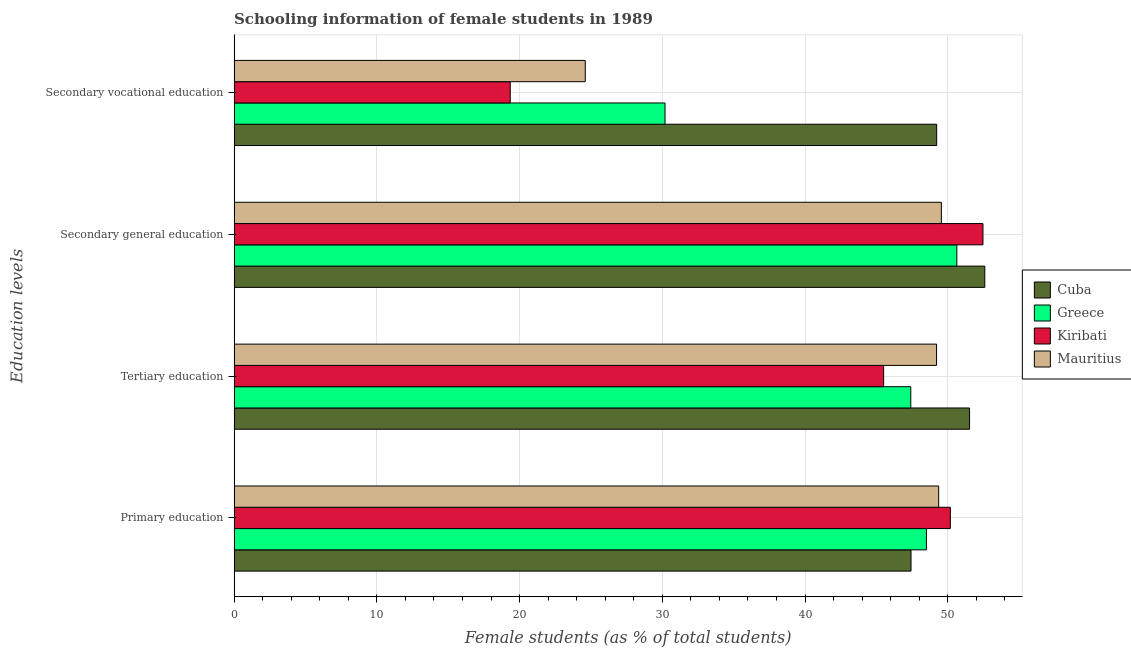How many different coloured bars are there?
Ensure brevity in your answer.  4. Are the number of bars on each tick of the Y-axis equal?
Ensure brevity in your answer.  Yes. How many bars are there on the 1st tick from the top?
Your answer should be compact. 4. How many bars are there on the 1st tick from the bottom?
Provide a succinct answer. 4. What is the label of the 2nd group of bars from the top?
Give a very brief answer. Secondary general education. What is the percentage of female students in tertiary education in Kiribati?
Ensure brevity in your answer.  45.5. Across all countries, what is the maximum percentage of female students in secondary education?
Offer a very short reply. 52.59. Across all countries, what is the minimum percentage of female students in secondary education?
Offer a very short reply. 49.55. In which country was the percentage of female students in tertiary education maximum?
Give a very brief answer. Cuba. In which country was the percentage of female students in primary education minimum?
Keep it short and to the point. Cuba. What is the total percentage of female students in secondary vocational education in the graph?
Provide a succinct answer. 123.35. What is the difference between the percentage of female students in tertiary education in Cuba and that in Mauritius?
Your response must be concise. 2.31. What is the difference between the percentage of female students in secondary vocational education in Cuba and the percentage of female students in tertiary education in Mauritius?
Your answer should be very brief. 0.01. What is the average percentage of female students in tertiary education per country?
Offer a very short reply. 48.41. What is the difference between the percentage of female students in primary education and percentage of female students in secondary education in Mauritius?
Provide a short and direct response. -0.19. What is the ratio of the percentage of female students in tertiary education in Cuba to that in Kiribati?
Provide a succinct answer. 1.13. Is the percentage of female students in secondary vocational education in Cuba less than that in Greece?
Offer a terse response. No. Is the difference between the percentage of female students in tertiary education in Greece and Kiribati greater than the difference between the percentage of female students in secondary vocational education in Greece and Kiribati?
Provide a short and direct response. No. What is the difference between the highest and the second highest percentage of female students in primary education?
Give a very brief answer. 0.82. What is the difference between the highest and the lowest percentage of female students in primary education?
Ensure brevity in your answer.  2.76. In how many countries, is the percentage of female students in secondary education greater than the average percentage of female students in secondary education taken over all countries?
Provide a succinct answer. 2. Is the sum of the percentage of female students in secondary vocational education in Mauritius and Greece greater than the maximum percentage of female students in primary education across all countries?
Give a very brief answer. Yes. What does the 3rd bar from the bottom in Tertiary education represents?
Keep it short and to the point. Kiribati. Is it the case that in every country, the sum of the percentage of female students in primary education and percentage of female students in tertiary education is greater than the percentage of female students in secondary education?
Your answer should be compact. Yes. How many countries are there in the graph?
Keep it short and to the point. 4. Where does the legend appear in the graph?
Offer a very short reply. Center right. How are the legend labels stacked?
Your answer should be compact. Vertical. What is the title of the graph?
Provide a succinct answer. Schooling information of female students in 1989. Does "Greenland" appear as one of the legend labels in the graph?
Offer a terse response. No. What is the label or title of the X-axis?
Your answer should be compact. Female students (as % of total students). What is the label or title of the Y-axis?
Offer a terse response. Education levels. What is the Female students (as % of total students) in Cuba in Primary education?
Provide a short and direct response. 47.42. What is the Female students (as % of total students) in Greece in Primary education?
Make the answer very short. 48.5. What is the Female students (as % of total students) of Kiribati in Primary education?
Make the answer very short. 50.18. What is the Female students (as % of total students) of Mauritius in Primary education?
Your response must be concise. 49.36. What is the Female students (as % of total students) of Cuba in Tertiary education?
Your answer should be compact. 51.52. What is the Female students (as % of total students) in Greece in Tertiary education?
Ensure brevity in your answer.  47.41. What is the Female students (as % of total students) of Kiribati in Tertiary education?
Your response must be concise. 45.5. What is the Female students (as % of total students) of Mauritius in Tertiary education?
Provide a succinct answer. 49.21. What is the Female students (as % of total students) in Cuba in Secondary general education?
Make the answer very short. 52.59. What is the Female students (as % of total students) in Greece in Secondary general education?
Offer a very short reply. 50.63. What is the Female students (as % of total students) in Kiribati in Secondary general education?
Offer a very short reply. 52.46. What is the Female students (as % of total students) in Mauritius in Secondary general education?
Provide a short and direct response. 49.55. What is the Female students (as % of total students) of Cuba in Secondary vocational education?
Your answer should be very brief. 49.22. What is the Female students (as % of total students) in Greece in Secondary vocational education?
Make the answer very short. 30.19. What is the Female students (as % of total students) in Kiribati in Secondary vocational education?
Keep it short and to the point. 19.34. What is the Female students (as % of total students) of Mauritius in Secondary vocational education?
Provide a short and direct response. 24.6. Across all Education levels, what is the maximum Female students (as % of total students) in Cuba?
Make the answer very short. 52.59. Across all Education levels, what is the maximum Female students (as % of total students) of Greece?
Offer a terse response. 50.63. Across all Education levels, what is the maximum Female students (as % of total students) of Kiribati?
Make the answer very short. 52.46. Across all Education levels, what is the maximum Female students (as % of total students) of Mauritius?
Your answer should be very brief. 49.55. Across all Education levels, what is the minimum Female students (as % of total students) of Cuba?
Your response must be concise. 47.42. Across all Education levels, what is the minimum Female students (as % of total students) of Greece?
Offer a terse response. 30.19. Across all Education levels, what is the minimum Female students (as % of total students) of Kiribati?
Provide a short and direct response. 19.34. Across all Education levels, what is the minimum Female students (as % of total students) of Mauritius?
Make the answer very short. 24.6. What is the total Female students (as % of total students) of Cuba in the graph?
Your response must be concise. 200.76. What is the total Female students (as % of total students) of Greece in the graph?
Provide a succinct answer. 176.73. What is the total Female students (as % of total students) of Kiribati in the graph?
Make the answer very short. 167.49. What is the total Female students (as % of total students) of Mauritius in the graph?
Your answer should be very brief. 172.73. What is the difference between the Female students (as % of total students) of Cuba in Primary education and that in Tertiary education?
Make the answer very short. -4.1. What is the difference between the Female students (as % of total students) of Greece in Primary education and that in Tertiary education?
Provide a succinct answer. 1.09. What is the difference between the Female students (as % of total students) in Kiribati in Primary education and that in Tertiary education?
Offer a terse response. 4.67. What is the difference between the Female students (as % of total students) of Mauritius in Primary education and that in Tertiary education?
Offer a terse response. 0.15. What is the difference between the Female students (as % of total students) in Cuba in Primary education and that in Secondary general education?
Keep it short and to the point. -5.17. What is the difference between the Female students (as % of total students) in Greece in Primary education and that in Secondary general education?
Your answer should be very brief. -2.13. What is the difference between the Female students (as % of total students) of Kiribati in Primary education and that in Secondary general education?
Give a very brief answer. -2.29. What is the difference between the Female students (as % of total students) of Mauritius in Primary education and that in Secondary general education?
Offer a very short reply. -0.19. What is the difference between the Female students (as % of total students) of Cuba in Primary education and that in Secondary vocational education?
Provide a succinct answer. -1.8. What is the difference between the Female students (as % of total students) in Greece in Primary education and that in Secondary vocational education?
Give a very brief answer. 18.31. What is the difference between the Female students (as % of total students) in Kiribati in Primary education and that in Secondary vocational education?
Your answer should be very brief. 30.83. What is the difference between the Female students (as % of total students) of Mauritius in Primary education and that in Secondary vocational education?
Your answer should be very brief. 24.76. What is the difference between the Female students (as % of total students) of Cuba in Tertiary education and that in Secondary general education?
Your answer should be very brief. -1.07. What is the difference between the Female students (as % of total students) in Greece in Tertiary education and that in Secondary general education?
Provide a short and direct response. -3.23. What is the difference between the Female students (as % of total students) of Kiribati in Tertiary education and that in Secondary general education?
Give a very brief answer. -6.96. What is the difference between the Female students (as % of total students) of Mauritius in Tertiary education and that in Secondary general education?
Offer a terse response. -0.34. What is the difference between the Female students (as % of total students) in Cuba in Tertiary education and that in Secondary vocational education?
Make the answer very short. 2.3. What is the difference between the Female students (as % of total students) in Greece in Tertiary education and that in Secondary vocational education?
Give a very brief answer. 17.22. What is the difference between the Female students (as % of total students) in Kiribati in Tertiary education and that in Secondary vocational education?
Keep it short and to the point. 26.16. What is the difference between the Female students (as % of total students) in Mauritius in Tertiary education and that in Secondary vocational education?
Your response must be concise. 24.61. What is the difference between the Female students (as % of total students) in Cuba in Secondary general education and that in Secondary vocational education?
Offer a terse response. 3.37. What is the difference between the Female students (as % of total students) of Greece in Secondary general education and that in Secondary vocational education?
Your answer should be very brief. 20.45. What is the difference between the Female students (as % of total students) in Kiribati in Secondary general education and that in Secondary vocational education?
Provide a short and direct response. 33.12. What is the difference between the Female students (as % of total students) in Mauritius in Secondary general education and that in Secondary vocational education?
Provide a short and direct response. 24.95. What is the difference between the Female students (as % of total students) in Cuba in Primary education and the Female students (as % of total students) in Greece in Tertiary education?
Give a very brief answer. 0.02. What is the difference between the Female students (as % of total students) of Cuba in Primary education and the Female students (as % of total students) of Kiribati in Tertiary education?
Make the answer very short. 1.92. What is the difference between the Female students (as % of total students) of Cuba in Primary education and the Female students (as % of total students) of Mauritius in Tertiary education?
Provide a short and direct response. -1.79. What is the difference between the Female students (as % of total students) in Greece in Primary education and the Female students (as % of total students) in Kiribati in Tertiary education?
Make the answer very short. 3. What is the difference between the Female students (as % of total students) in Greece in Primary education and the Female students (as % of total students) in Mauritius in Tertiary education?
Keep it short and to the point. -0.71. What is the difference between the Female students (as % of total students) in Kiribati in Primary education and the Female students (as % of total students) in Mauritius in Tertiary education?
Offer a very short reply. 0.97. What is the difference between the Female students (as % of total students) in Cuba in Primary education and the Female students (as % of total students) in Greece in Secondary general education?
Ensure brevity in your answer.  -3.21. What is the difference between the Female students (as % of total students) of Cuba in Primary education and the Female students (as % of total students) of Kiribati in Secondary general education?
Give a very brief answer. -5.04. What is the difference between the Female students (as % of total students) in Cuba in Primary education and the Female students (as % of total students) in Mauritius in Secondary general education?
Give a very brief answer. -2.13. What is the difference between the Female students (as % of total students) of Greece in Primary education and the Female students (as % of total students) of Kiribati in Secondary general education?
Your answer should be compact. -3.96. What is the difference between the Female students (as % of total students) in Greece in Primary education and the Female students (as % of total students) in Mauritius in Secondary general education?
Make the answer very short. -1.05. What is the difference between the Female students (as % of total students) of Kiribati in Primary education and the Female students (as % of total students) of Mauritius in Secondary general education?
Your response must be concise. 0.63. What is the difference between the Female students (as % of total students) of Cuba in Primary education and the Female students (as % of total students) of Greece in Secondary vocational education?
Offer a very short reply. 17.23. What is the difference between the Female students (as % of total students) in Cuba in Primary education and the Female students (as % of total students) in Kiribati in Secondary vocational education?
Your response must be concise. 28.08. What is the difference between the Female students (as % of total students) of Cuba in Primary education and the Female students (as % of total students) of Mauritius in Secondary vocational education?
Give a very brief answer. 22.82. What is the difference between the Female students (as % of total students) in Greece in Primary education and the Female students (as % of total students) in Kiribati in Secondary vocational education?
Ensure brevity in your answer.  29.16. What is the difference between the Female students (as % of total students) in Greece in Primary education and the Female students (as % of total students) in Mauritius in Secondary vocational education?
Keep it short and to the point. 23.9. What is the difference between the Female students (as % of total students) in Kiribati in Primary education and the Female students (as % of total students) in Mauritius in Secondary vocational education?
Offer a very short reply. 25.58. What is the difference between the Female students (as % of total students) of Cuba in Tertiary education and the Female students (as % of total students) of Greece in Secondary general education?
Make the answer very short. 0.89. What is the difference between the Female students (as % of total students) of Cuba in Tertiary education and the Female students (as % of total students) of Kiribati in Secondary general education?
Give a very brief answer. -0.94. What is the difference between the Female students (as % of total students) of Cuba in Tertiary education and the Female students (as % of total students) of Mauritius in Secondary general education?
Provide a succinct answer. 1.97. What is the difference between the Female students (as % of total students) in Greece in Tertiary education and the Female students (as % of total students) in Kiribati in Secondary general education?
Your answer should be compact. -5.06. What is the difference between the Female students (as % of total students) of Greece in Tertiary education and the Female students (as % of total students) of Mauritius in Secondary general education?
Ensure brevity in your answer.  -2.14. What is the difference between the Female students (as % of total students) in Kiribati in Tertiary education and the Female students (as % of total students) in Mauritius in Secondary general education?
Offer a terse response. -4.05. What is the difference between the Female students (as % of total students) of Cuba in Tertiary education and the Female students (as % of total students) of Greece in Secondary vocational education?
Offer a terse response. 21.34. What is the difference between the Female students (as % of total students) in Cuba in Tertiary education and the Female students (as % of total students) in Kiribati in Secondary vocational education?
Make the answer very short. 32.18. What is the difference between the Female students (as % of total students) in Cuba in Tertiary education and the Female students (as % of total students) in Mauritius in Secondary vocational education?
Give a very brief answer. 26.92. What is the difference between the Female students (as % of total students) in Greece in Tertiary education and the Female students (as % of total students) in Kiribati in Secondary vocational education?
Offer a very short reply. 28.06. What is the difference between the Female students (as % of total students) in Greece in Tertiary education and the Female students (as % of total students) in Mauritius in Secondary vocational education?
Your answer should be compact. 22.81. What is the difference between the Female students (as % of total students) in Kiribati in Tertiary education and the Female students (as % of total students) in Mauritius in Secondary vocational education?
Provide a succinct answer. 20.9. What is the difference between the Female students (as % of total students) in Cuba in Secondary general education and the Female students (as % of total students) in Greece in Secondary vocational education?
Make the answer very short. 22.4. What is the difference between the Female students (as % of total students) of Cuba in Secondary general education and the Female students (as % of total students) of Kiribati in Secondary vocational education?
Provide a succinct answer. 33.25. What is the difference between the Female students (as % of total students) of Cuba in Secondary general education and the Female students (as % of total students) of Mauritius in Secondary vocational education?
Your answer should be very brief. 27.99. What is the difference between the Female students (as % of total students) in Greece in Secondary general education and the Female students (as % of total students) in Kiribati in Secondary vocational education?
Keep it short and to the point. 31.29. What is the difference between the Female students (as % of total students) in Greece in Secondary general education and the Female students (as % of total students) in Mauritius in Secondary vocational education?
Keep it short and to the point. 26.03. What is the difference between the Female students (as % of total students) of Kiribati in Secondary general education and the Female students (as % of total students) of Mauritius in Secondary vocational education?
Offer a very short reply. 27.86. What is the average Female students (as % of total students) in Cuba per Education levels?
Keep it short and to the point. 50.19. What is the average Female students (as % of total students) of Greece per Education levels?
Your answer should be compact. 44.18. What is the average Female students (as % of total students) of Kiribati per Education levels?
Make the answer very short. 41.87. What is the average Female students (as % of total students) in Mauritius per Education levels?
Make the answer very short. 43.18. What is the difference between the Female students (as % of total students) in Cuba and Female students (as % of total students) in Greece in Primary education?
Your answer should be compact. -1.08. What is the difference between the Female students (as % of total students) in Cuba and Female students (as % of total students) in Kiribati in Primary education?
Keep it short and to the point. -2.76. What is the difference between the Female students (as % of total students) of Cuba and Female students (as % of total students) of Mauritius in Primary education?
Make the answer very short. -1.94. What is the difference between the Female students (as % of total students) of Greece and Female students (as % of total students) of Kiribati in Primary education?
Provide a succinct answer. -1.68. What is the difference between the Female students (as % of total students) in Greece and Female students (as % of total students) in Mauritius in Primary education?
Give a very brief answer. -0.86. What is the difference between the Female students (as % of total students) of Kiribati and Female students (as % of total students) of Mauritius in Primary education?
Keep it short and to the point. 0.82. What is the difference between the Female students (as % of total students) in Cuba and Female students (as % of total students) in Greece in Tertiary education?
Your response must be concise. 4.12. What is the difference between the Female students (as % of total students) in Cuba and Female students (as % of total students) in Kiribati in Tertiary education?
Provide a short and direct response. 6.02. What is the difference between the Female students (as % of total students) in Cuba and Female students (as % of total students) in Mauritius in Tertiary education?
Provide a short and direct response. 2.31. What is the difference between the Female students (as % of total students) of Greece and Female students (as % of total students) of Kiribati in Tertiary education?
Your answer should be very brief. 1.9. What is the difference between the Female students (as % of total students) in Greece and Female students (as % of total students) in Mauritius in Tertiary education?
Provide a short and direct response. -1.81. What is the difference between the Female students (as % of total students) in Kiribati and Female students (as % of total students) in Mauritius in Tertiary education?
Your answer should be very brief. -3.71. What is the difference between the Female students (as % of total students) of Cuba and Female students (as % of total students) of Greece in Secondary general education?
Provide a succinct answer. 1.96. What is the difference between the Female students (as % of total students) in Cuba and Female students (as % of total students) in Kiribati in Secondary general education?
Offer a terse response. 0.13. What is the difference between the Female students (as % of total students) in Cuba and Female students (as % of total students) in Mauritius in Secondary general education?
Keep it short and to the point. 3.04. What is the difference between the Female students (as % of total students) of Greece and Female students (as % of total students) of Kiribati in Secondary general education?
Offer a terse response. -1.83. What is the difference between the Female students (as % of total students) in Greece and Female students (as % of total students) in Mauritius in Secondary general education?
Your response must be concise. 1.08. What is the difference between the Female students (as % of total students) of Kiribati and Female students (as % of total students) of Mauritius in Secondary general education?
Make the answer very short. 2.91. What is the difference between the Female students (as % of total students) in Cuba and Female students (as % of total students) in Greece in Secondary vocational education?
Make the answer very short. 19.03. What is the difference between the Female students (as % of total students) of Cuba and Female students (as % of total students) of Kiribati in Secondary vocational education?
Provide a short and direct response. 29.88. What is the difference between the Female students (as % of total students) of Cuba and Female students (as % of total students) of Mauritius in Secondary vocational education?
Keep it short and to the point. 24.62. What is the difference between the Female students (as % of total students) of Greece and Female students (as % of total students) of Kiribati in Secondary vocational education?
Make the answer very short. 10.84. What is the difference between the Female students (as % of total students) in Greece and Female students (as % of total students) in Mauritius in Secondary vocational education?
Your answer should be very brief. 5.59. What is the difference between the Female students (as % of total students) of Kiribati and Female students (as % of total students) of Mauritius in Secondary vocational education?
Offer a very short reply. -5.26. What is the ratio of the Female students (as % of total students) of Cuba in Primary education to that in Tertiary education?
Offer a very short reply. 0.92. What is the ratio of the Female students (as % of total students) of Greece in Primary education to that in Tertiary education?
Offer a terse response. 1.02. What is the ratio of the Female students (as % of total students) in Kiribati in Primary education to that in Tertiary education?
Provide a succinct answer. 1.1. What is the ratio of the Female students (as % of total students) in Mauritius in Primary education to that in Tertiary education?
Your response must be concise. 1. What is the ratio of the Female students (as % of total students) in Cuba in Primary education to that in Secondary general education?
Offer a terse response. 0.9. What is the ratio of the Female students (as % of total students) in Greece in Primary education to that in Secondary general education?
Your response must be concise. 0.96. What is the ratio of the Female students (as % of total students) in Kiribati in Primary education to that in Secondary general education?
Provide a short and direct response. 0.96. What is the ratio of the Female students (as % of total students) of Mauritius in Primary education to that in Secondary general education?
Give a very brief answer. 1. What is the ratio of the Female students (as % of total students) in Cuba in Primary education to that in Secondary vocational education?
Provide a succinct answer. 0.96. What is the ratio of the Female students (as % of total students) in Greece in Primary education to that in Secondary vocational education?
Your answer should be compact. 1.61. What is the ratio of the Female students (as % of total students) of Kiribati in Primary education to that in Secondary vocational education?
Ensure brevity in your answer.  2.59. What is the ratio of the Female students (as % of total students) in Mauritius in Primary education to that in Secondary vocational education?
Provide a succinct answer. 2.01. What is the ratio of the Female students (as % of total students) of Cuba in Tertiary education to that in Secondary general education?
Provide a short and direct response. 0.98. What is the ratio of the Female students (as % of total students) in Greece in Tertiary education to that in Secondary general education?
Make the answer very short. 0.94. What is the ratio of the Female students (as % of total students) in Kiribati in Tertiary education to that in Secondary general education?
Make the answer very short. 0.87. What is the ratio of the Female students (as % of total students) in Mauritius in Tertiary education to that in Secondary general education?
Your answer should be compact. 0.99. What is the ratio of the Female students (as % of total students) of Cuba in Tertiary education to that in Secondary vocational education?
Provide a short and direct response. 1.05. What is the ratio of the Female students (as % of total students) in Greece in Tertiary education to that in Secondary vocational education?
Keep it short and to the point. 1.57. What is the ratio of the Female students (as % of total students) of Kiribati in Tertiary education to that in Secondary vocational education?
Give a very brief answer. 2.35. What is the ratio of the Female students (as % of total students) in Mauritius in Tertiary education to that in Secondary vocational education?
Keep it short and to the point. 2. What is the ratio of the Female students (as % of total students) in Cuba in Secondary general education to that in Secondary vocational education?
Your response must be concise. 1.07. What is the ratio of the Female students (as % of total students) in Greece in Secondary general education to that in Secondary vocational education?
Offer a very short reply. 1.68. What is the ratio of the Female students (as % of total students) of Kiribati in Secondary general education to that in Secondary vocational education?
Provide a succinct answer. 2.71. What is the ratio of the Female students (as % of total students) in Mauritius in Secondary general education to that in Secondary vocational education?
Offer a very short reply. 2.01. What is the difference between the highest and the second highest Female students (as % of total students) in Cuba?
Offer a terse response. 1.07. What is the difference between the highest and the second highest Female students (as % of total students) in Greece?
Give a very brief answer. 2.13. What is the difference between the highest and the second highest Female students (as % of total students) in Kiribati?
Keep it short and to the point. 2.29. What is the difference between the highest and the second highest Female students (as % of total students) in Mauritius?
Provide a short and direct response. 0.19. What is the difference between the highest and the lowest Female students (as % of total students) of Cuba?
Make the answer very short. 5.17. What is the difference between the highest and the lowest Female students (as % of total students) in Greece?
Your response must be concise. 20.45. What is the difference between the highest and the lowest Female students (as % of total students) in Kiribati?
Offer a very short reply. 33.12. What is the difference between the highest and the lowest Female students (as % of total students) in Mauritius?
Ensure brevity in your answer.  24.95. 